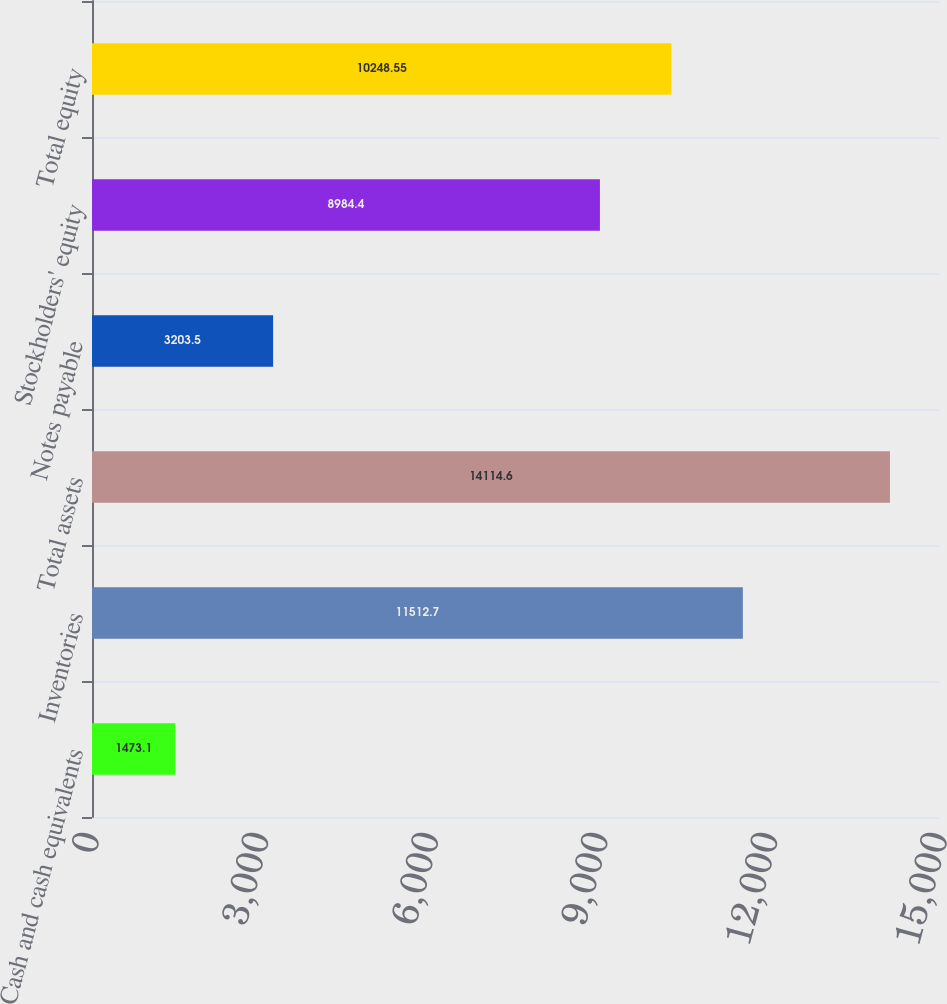Convert chart. <chart><loc_0><loc_0><loc_500><loc_500><bar_chart><fcel>Cash and cash equivalents<fcel>Inventories<fcel>Total assets<fcel>Notes payable<fcel>Stockholders' equity<fcel>Total equity<nl><fcel>1473.1<fcel>11512.7<fcel>14114.6<fcel>3203.5<fcel>8984.4<fcel>10248.5<nl></chart> 